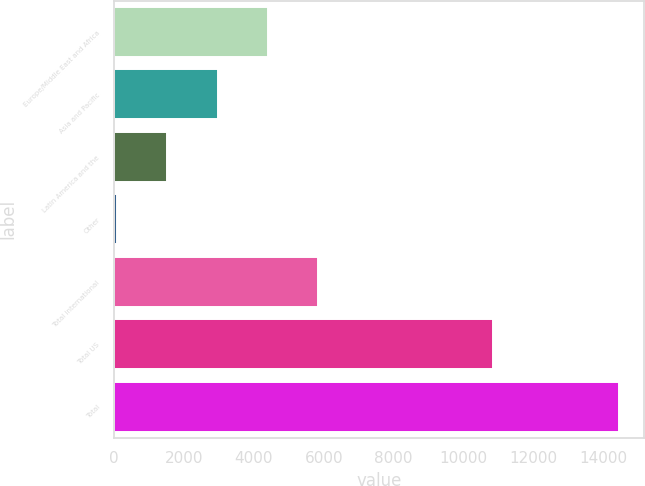<chart> <loc_0><loc_0><loc_500><loc_500><bar_chart><fcel>Europe/Middle East and Africa<fcel>Asia and Pacific<fcel>Latin America and the<fcel>Other<fcel>Total international<fcel>Total US<fcel>Total<nl><fcel>4396.2<fcel>2960.8<fcel>1525.4<fcel>90<fcel>5831.6<fcel>10847<fcel>14444<nl></chart> 